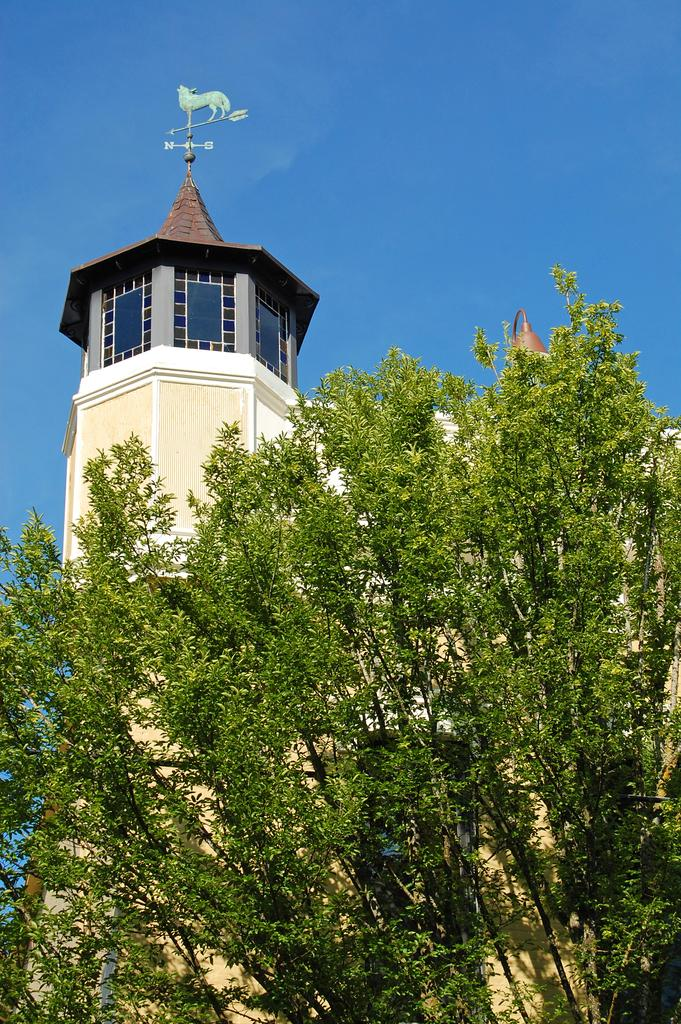What type of structure is present in the picture? There is a building in the picture. What other natural elements can be seen in the picture? There are trees in the picture. What part of the natural environment is visible in the picture? The sky is visible in the picture. How many dinosaurs can be seen grazing in the market in the picture? There are no dinosaurs or markets present in the picture; it features a building, trees, and the sky. 